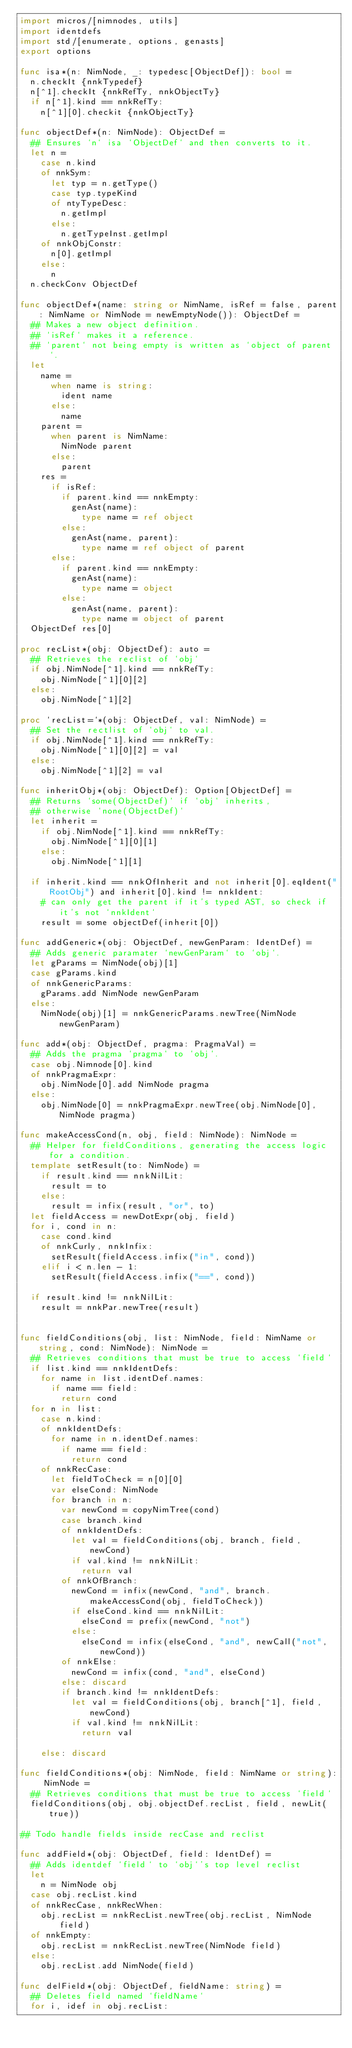Convert code to text. <code><loc_0><loc_0><loc_500><loc_500><_Nim_>import micros/[nimnodes, utils]
import identdefs
import std/[enumerate, options, genasts]
export options

func isa*(n: NimNode, _: typedesc[ObjectDef]): bool =
  n.checkIt {nnkTypedef}
  n[^1].checkIt {nnkRefTy, nnkObjectTy}
  if n[^1].kind == nnkRefTy:
    n[^1][0].checkit {nnkObjectTy}

func objectDef*(n: NimNode): ObjectDef =
  ## Ensures `n` isa `ObjectDef` and then converts to it.
  let n =
    case n.kind
    of nnkSym:
      let typ = n.getType()
      case typ.typeKind
      of ntyTypeDesc:
        n.getImpl
      else:
        n.getTypeInst.getImpl
    of nnkObjConstr:
      n[0].getImpl
    else:
      n
  n.checkConv ObjectDef

func objectDef*(name: string or NimName, isRef = false, parent: NimName or NimNode = newEmptyNode()): ObjectDef =
  ## Makes a new object definition.
  ## `isRef` makes it a reference.
  ## `parent` not being empty is written as `object of parent`.
  let
    name =
      when name is string:
        ident name
      else:
        name
    parent =
      when parent is NimName:
        NimNode parent
      else:
        parent
    res =
      if isRef:
        if parent.kind == nnkEmpty:
          genAst(name):
            type name = ref object
        else:
          genAst(name, parent):
            type name = ref object of parent
      else:
        if parent.kind == nnkEmpty:
          genAst(name):
            type name = object
        else:
          genAst(name, parent):
            type name = object of parent
  ObjectDef res[0]

proc recList*(obj: ObjectDef): auto =
  ## Retrieves the reclist of `obj`
  if obj.NimNode[^1].kind == nnkRefTy:
    obj.NimNode[^1][0][2]
  else:
    obj.NimNode[^1][2]

proc `recList=`*(obj: ObjectDef, val: NimNode) =
  ## Set the rectlist of `obj` to val.
  if obj.NimNode[^1].kind == nnkRefTy:
    obj.NimNode[^1][0][2] = val
  else:
    obj.NimNode[^1][2] = val

func inheritObj*(obj: ObjectDef): Option[ObjectDef] =
  ## Returns `some(ObjectDef)` if `obj` inherits,
  ## otherwise `none(ObjectDef)`
  let inherit =
    if obj.NimNode[^1].kind == nnkRefTy:
      obj.NimNode[^1][0][1]
    else:
      obj.NimNode[^1][1]

  if inherit.kind == nnkOfInherit and not inherit[0].eqIdent("RootObj") and inherit[0].kind != nnkIdent:
    # can only get the parent if it's typed AST, so check if it's not `nnkIdent`
    result = some objectDef(inherit[0])

func addGeneric*(obj: ObjectDef, newGenParam: IdentDef) =
  ## Adds generic paramater `newGenParam` to `obj`.
  let gParams = NimNode(obj)[1]
  case gParams.kind
  of nnkGenericParams:
    gParams.add NimNode newGenParam
  else:
    NimNode(obj)[1] = nnkGenericParams.newTree(NimNode newGenParam)

func add*(obj: ObjectDef, pragma: PragmaVal) =
  ## Adds the pragma `pragma` to `obj`.
  case obj.Nimnode[0].kind
  of nnkPragmaExpr:
    obj.NimNode[0].add NimNode pragma
  else:
    obj.NimNode[0] = nnkPragmaExpr.newTree(obj.NimNode[0], NimNode pragma)

func makeAccessCond(n, obj, field: NimNode): NimNode =
  ## Helper for fieldConditions, generating the access logic for a condition.
  template setResult(to: NimNode) =
    if result.kind == nnkNilLit:
      result = to
    else:
      result = infix(result, "or", to)
  let fieldAccess = newDotExpr(obj, field)
  for i, cond in n:
    case cond.kind
    of nnkCurly, nnkInfix:
      setResult(fieldAccess.infix("in", cond))
    elif i < n.len - 1:
      setResult(fieldAccess.infix("==", cond))

  if result.kind != nnkNilLit:
    result = nnkPar.newTree(result)


func fieldConditions(obj, list: NimNode, field: NimName or string, cond: NimNode): NimNode =
  ## Retrieves conditions that must be true to access `field`
  if list.kind == nnkIdentDefs:
    for name in list.identDef.names:
      if name == field:
        return cond
  for n in list:
    case n.kind:
    of nnkIdentDefs:
      for name in n.identDef.names:
        if name == field:
          return cond
    of nnkRecCase:
      let fieldToCheck = n[0][0]
      var elseCond: NimNode
      for branch in n:
        var newCond = copyNimTree(cond)
        case branch.kind
        of nnkIdentDefs:
          let val = fieldConditions(obj, branch, field, newCond)
          if val.kind != nnkNilLit:
            return val
        of nnkOfBranch:
          newCond = infix(newCond, "and", branch.makeAccessCond(obj, fieldToCheck))
          if elseCond.kind == nnkNilLit:
            elseCond = prefix(newCond, "not")
          else:
            elseCond = infix(elseCond, "and", newCall("not", newCond))
        of nnkElse:
          newCond = infix(cond, "and", elseCond)
        else: discard
        if branch.kind != nnkIdentDefs:
          let val = fieldConditions(obj, branch[^1], field, newCond)
          if val.kind != nnkNilLit:
            return val

    else: discard

func fieldConditions*(obj: NimNode, field: NimName or string): NimNode =
  ## Retrieves conditions that must be true to access `field`
  fieldConditions(obj, obj.objectDef.recList, field, newLit(true))

## Todo handle fields inside recCase and reclist

func addField*(obj: ObjectDef, field: IdentDef) =
  ## Adds identdef `field` to `obj`'s top level reclist
  let
    n = NimNode obj
  case obj.recList.kind
  of nnkRecCase, nnkRecWhen:
    obj.recList = nnkRecList.newTree(obj.recList, NimNode field)
  of nnkEmpty:
    obj.recList = nnkRecList.newTree(NimNode field)
  else:
    obj.recList.add NimNode(field)

func delField*(obj: ObjectDef, fieldName: string) =
  ## Deletes field named `fieldName`
  for i, idef in obj.recList:</code> 